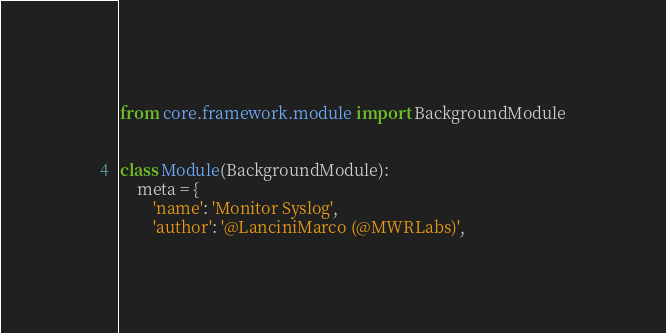Convert code to text. <code><loc_0><loc_0><loc_500><loc_500><_Python_>from core.framework.module import BackgroundModule


class Module(BackgroundModule):
    meta = {
        'name': 'Monitor Syslog',
        'author': '@LanciniMarco (@MWRLabs)',</code> 